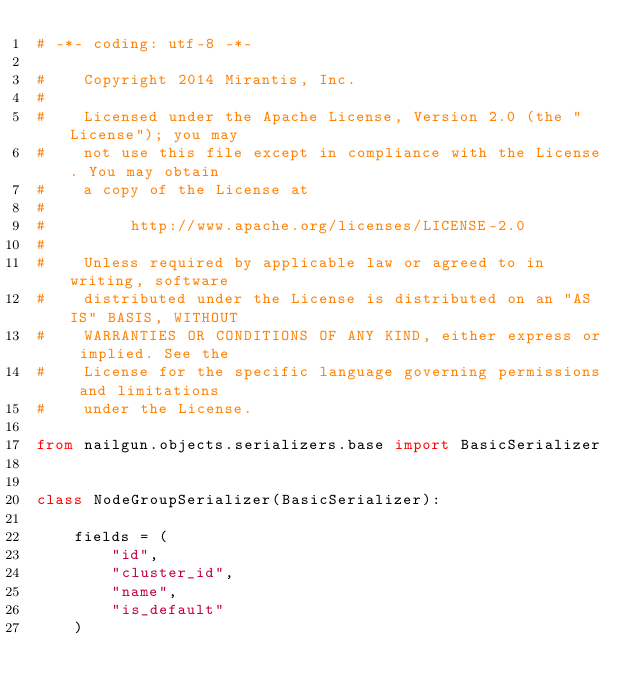<code> <loc_0><loc_0><loc_500><loc_500><_Python_># -*- coding: utf-8 -*-

#    Copyright 2014 Mirantis, Inc.
#
#    Licensed under the Apache License, Version 2.0 (the "License"); you may
#    not use this file except in compliance with the License. You may obtain
#    a copy of the License at
#
#         http://www.apache.org/licenses/LICENSE-2.0
#
#    Unless required by applicable law or agreed to in writing, software
#    distributed under the License is distributed on an "AS IS" BASIS, WITHOUT
#    WARRANTIES OR CONDITIONS OF ANY KIND, either express or implied. See the
#    License for the specific language governing permissions and limitations
#    under the License.

from nailgun.objects.serializers.base import BasicSerializer


class NodeGroupSerializer(BasicSerializer):

    fields = (
        "id",
        "cluster_id",
        "name",
        "is_default"
    )
</code> 